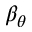<formula> <loc_0><loc_0><loc_500><loc_500>\beta _ { \theta }</formula> 